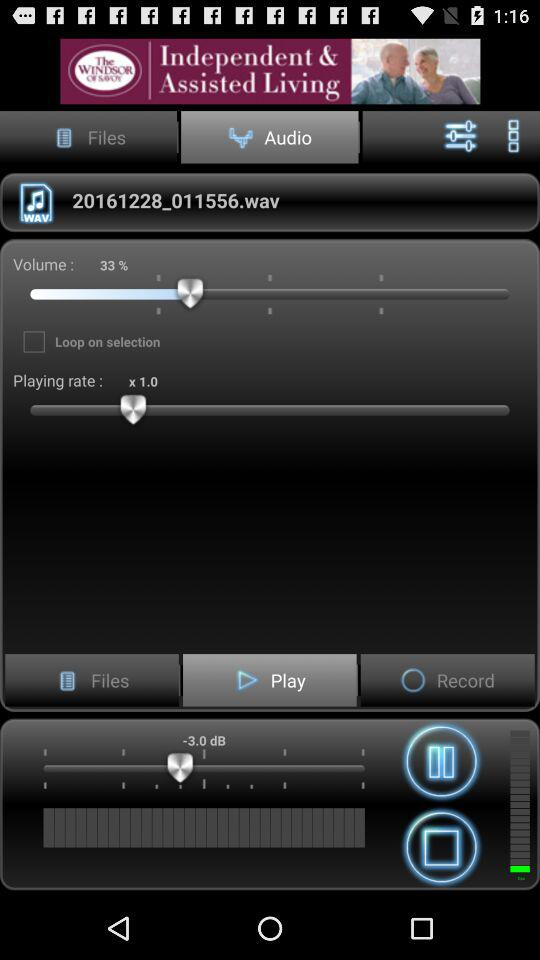What is the playing rate? The playing rate is 1.0x. 